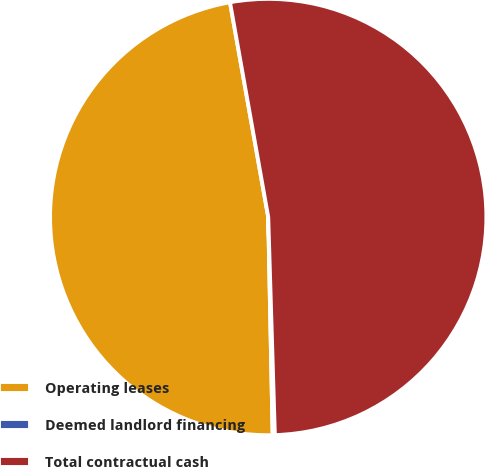Convert chart. <chart><loc_0><loc_0><loc_500><loc_500><pie_chart><fcel>Operating leases<fcel>Deemed landlord financing<fcel>Total contractual cash<nl><fcel>47.52%<fcel>0.16%<fcel>52.32%<nl></chart> 